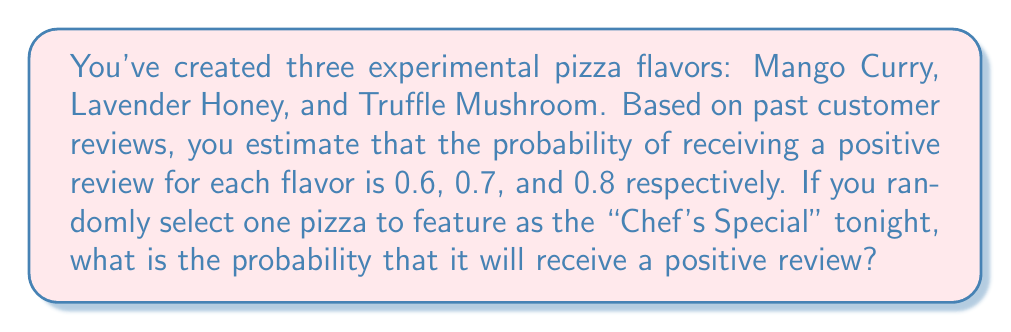Show me your answer to this math problem. Let's approach this step-by-step:

1) First, we need to understand what the question is asking. We're looking for the probability of a positive review for a randomly selected pizza from the three options.

2) We're given the following probabilities:
   P(Mango Curry positive) = 0.6
   P(Lavender Honey positive) = 0.7
   P(Truffle Mushroom positive) = 0.8

3) Since the pizza is selected randomly, each pizza has an equal probability of being chosen, which is $\frac{1}{3}$.

4) We can use the law of total probability here. The probability of a positive review is the sum of the probabilities of each pizza being chosen multiplied by its probability of getting a positive review.

5) Mathematically, this can be expressed as:

   $$P(\text{Positive}) = P(\text{Mango})\cdot P(\text{Positive|Mango}) + P(\text{Lavender})\cdot P(\text{Positive|Lavender}) + P(\text{Truffle})\cdot P(\text{Positive|Truffle})$$

6) Substituting the values:

   $$P(\text{Positive}) = \frac{1}{3} \cdot 0.6 + \frac{1}{3} \cdot 0.7 + \frac{1}{3} \cdot 0.8$$

7) Simplifying:

   $$P(\text{Positive}) = \frac{0.6 + 0.7 + 0.8}{3} = \frac{2.1}{3} = 0.7$$

Therefore, the probability of receiving a positive review for the randomly selected "Chef's Special" pizza is 0.7 or 70%.
Answer: 0.7 